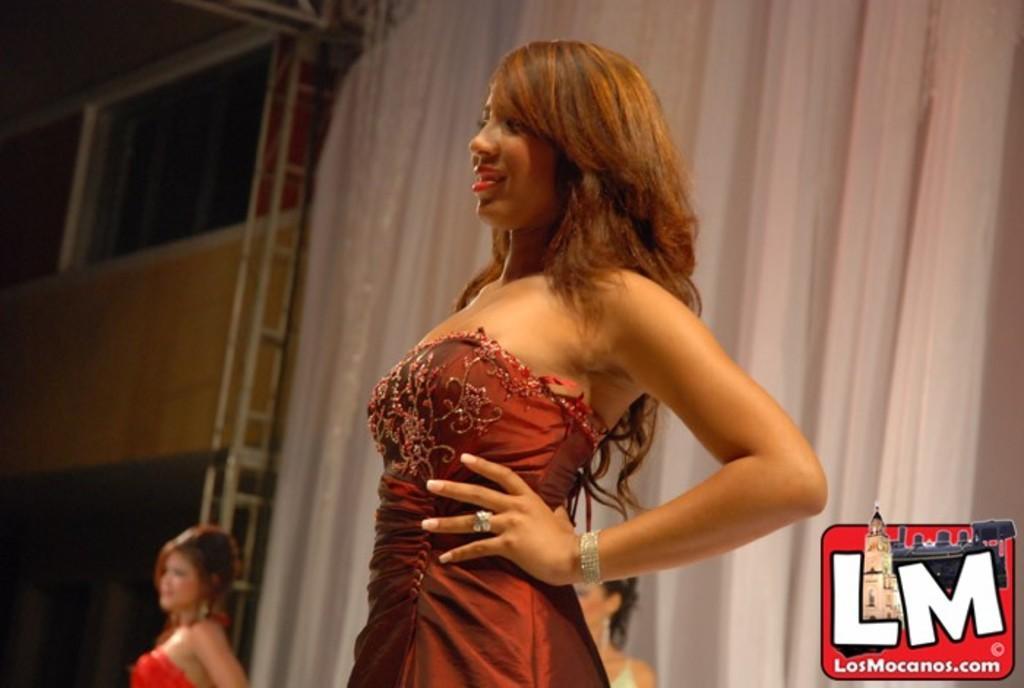Please provide a concise description of this image. In this picture we can see a woman smiling and in the background we can see two women, curtains, window, wall, some objects and at the bottom right corner of this picture we can see the logo. 